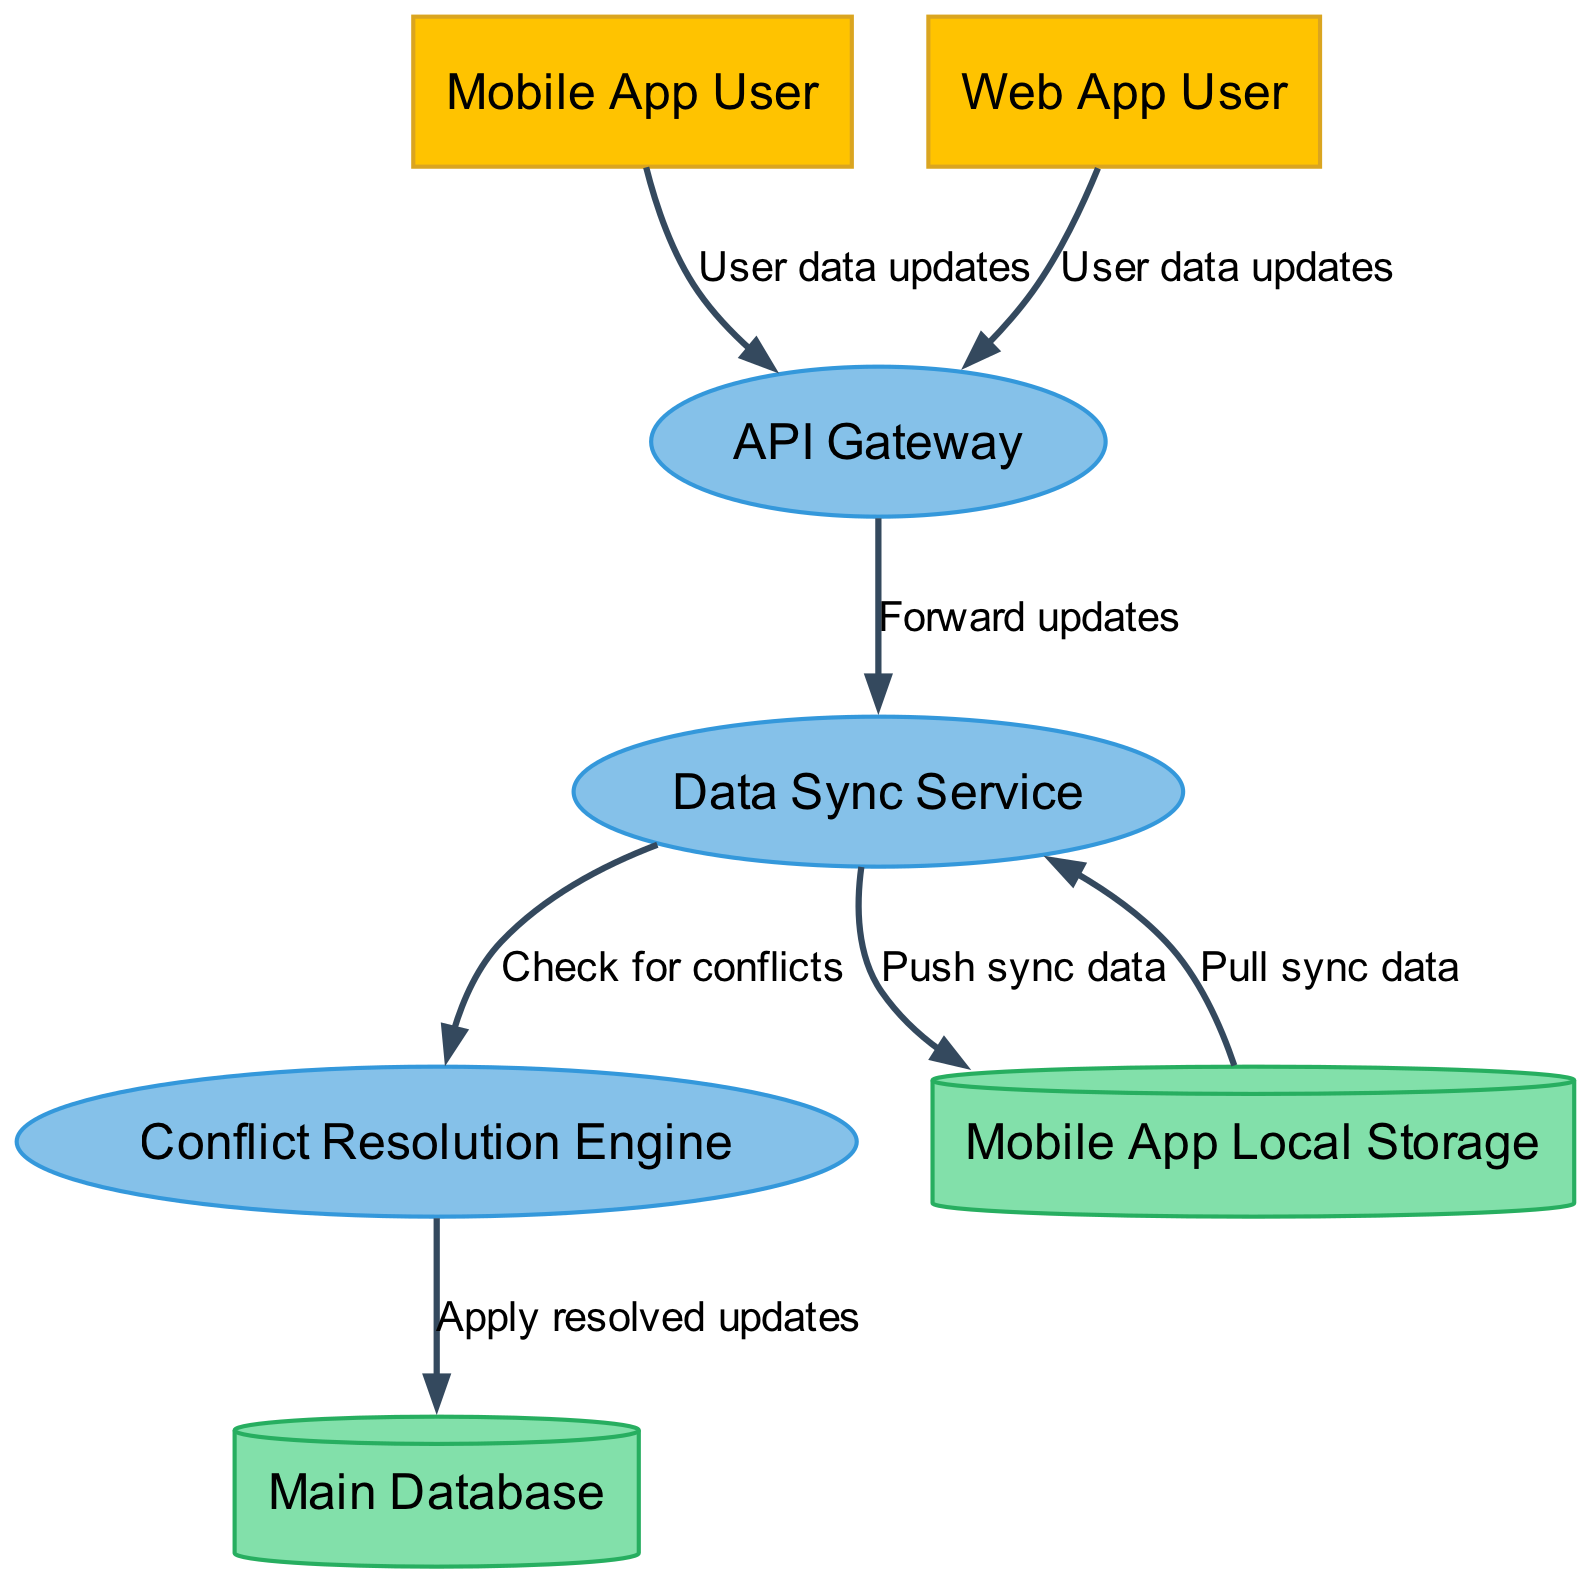What are the external entities in the diagram? The diagram indicates two external entities: the Mobile App User and the Web App User. These users interact with the system, which is represented in the outer part of the diagram.
Answer: Mobile App User, Web App User How many processes are there in the diagram? The diagram includes three processes: API Gateway, Data Sync Service, and Conflict Resolution Engine. Counting these processes gives us the total.
Answer: 3 What flows from the API Gateway to the Data Sync Service? According to the data flow indicated in the diagram, the API Gateway forwards updates to the Data Sync Service as part of the data synchronization process.
Answer: Forward updates Which component is responsible for checking for conflicts? The diagram specifies that the Conflict Resolution Engine checks for conflicts between data updates to ensure that all data is accurately synced across different platforms.
Answer: Conflict Resolution Engine How does Mobile App Local Storage receive sync data? The diagram shows that the Data Sync Service is responsible for pushing sync data to the Mobile App Local Storage, thus updating the local app with the necessary information.
Answer: Push sync data Which data store applies resolved updates? The Conflict Resolution Engine sends the resolved updates to the Main Database, ensuring that the changes from either the Mobile App or Web App are accurately saved in the main data repository.
Answer: Main Database What are the data flows between the Mobile App Local Storage and the Data Sync Service? The Mobile App Local Storage pulls sync data from the Data Sync Service and also receives data pushed from it. This two-way interaction ensures the mobile app stays up-to-date.
Answer: Pull sync data, Push sync data Which process acts as the central point for receiving updates from users? The API Gateway serves as the central process that receives user data updates from both the Mobile App User and the Web App User, facilitating the synchronization process for the entire system.
Answer: API Gateway 